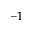<formula> <loc_0><loc_0><loc_500><loc_500>- 1</formula> 